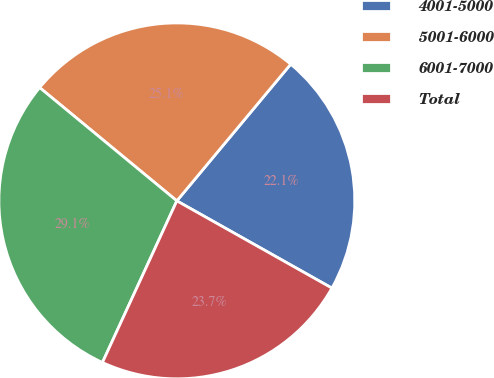Convert chart. <chart><loc_0><loc_0><loc_500><loc_500><pie_chart><fcel>4001-5000<fcel>5001-6000<fcel>6001-7000<fcel>Total<nl><fcel>22.1%<fcel>25.07%<fcel>29.12%<fcel>23.71%<nl></chart> 